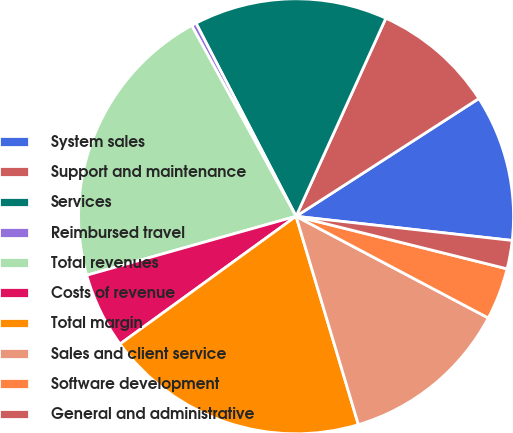Convert chart to OTSL. <chart><loc_0><loc_0><loc_500><loc_500><pie_chart><fcel>System sales<fcel>Support and maintenance<fcel>Services<fcel>Reimbursed travel<fcel>Total revenues<fcel>Costs of revenue<fcel>Total margin<fcel>Sales and client service<fcel>Software development<fcel>General and administrative<nl><fcel>10.88%<fcel>9.12%<fcel>14.38%<fcel>0.36%<fcel>21.4%<fcel>5.62%<fcel>19.64%<fcel>12.63%<fcel>3.86%<fcel>2.11%<nl></chart> 